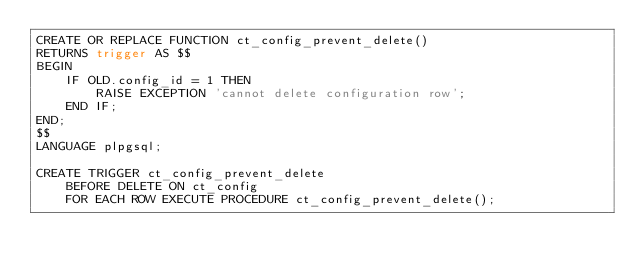<code> <loc_0><loc_0><loc_500><loc_500><_SQL_>CREATE OR REPLACE FUNCTION ct_config_prevent_delete() 
RETURNS trigger AS $$
BEGIN            
	IF OLD.config_id = 1 THEN
		RAISE EXCEPTION 'cannot delete configuration row';
	END IF;
END;
$$ 
LANGUAGE plpgsql;

CREATE TRIGGER ct_config_prevent_delete 
	BEFORE DELETE ON ct_config
	FOR EACH ROW EXECUTE PROCEDURE ct_config_prevent_delete();
</code> 